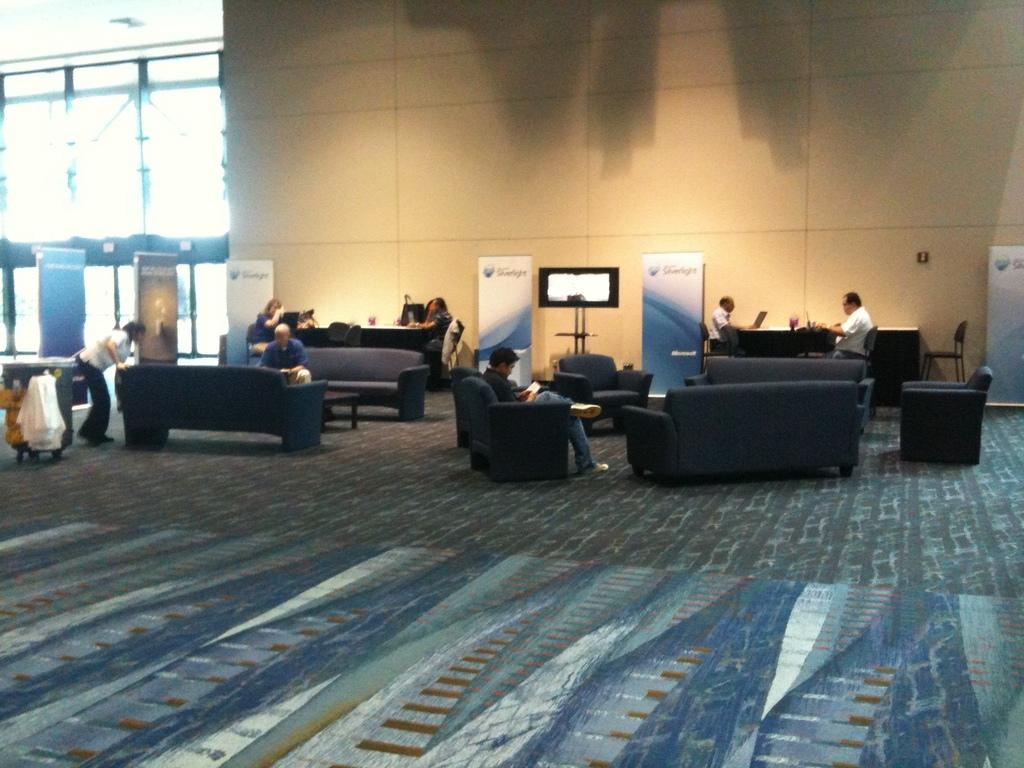What type of view is shown in the image? The image is an inside view. What are the people in the image doing? The people are sitting on chairs in the image. What can be seen in the background of the image? There is a wall, a window, and boards in the background of the image. How many bikes are parked near the people in the image? There are no bikes present in the image. What type of lift is visible in the background of the image? There is no lift visible in the background of the image. 